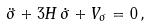Convert formula to latex. <formula><loc_0><loc_0><loc_500><loc_500>\ddot { \sigma } + 3 H \, \dot { \sigma } + V _ { \sigma } = 0 \, ,</formula> 